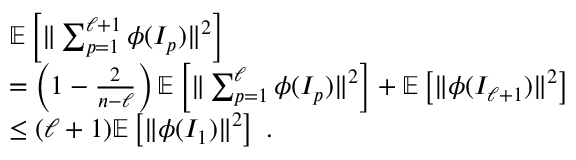Convert formula to latex. <formula><loc_0><loc_0><loc_500><loc_500>\begin{array} { r l } & { \mathbb { E } \left [ \| \sum _ { p = 1 } ^ { \ell + 1 } \phi ( I _ { p } ) \| ^ { 2 } \right ] } \\ & { = \left ( 1 - \frac { 2 } { n - \ell } \right ) \mathbb { E } \left [ \| \sum _ { p = 1 } ^ { \ell } \phi ( I _ { p } ) \| ^ { 2 } \right ] + \mathbb { E } \left [ \| \phi ( I _ { \ell + 1 } ) \| ^ { 2 } \right ] } \\ & { \leq ( \ell + 1 ) \mathbb { E } \left [ \| \phi ( I _ { 1 } ) \| ^ { 2 } \right ] \, . } \end{array}</formula> 